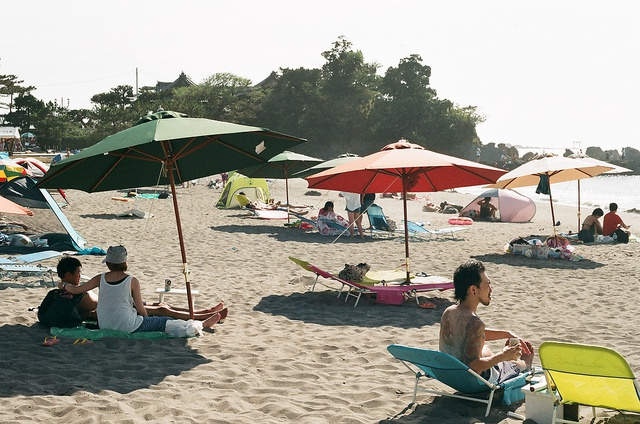Describe the objects in this image and their specific colors. I can see umbrella in white, black, teal, and beige tones, umbrella in white, brown, maroon, and tan tones, chair in white, khaki, olive, and black tones, people in white, gray, black, and maroon tones, and chair in white, black, teal, gray, and darkgray tones in this image. 